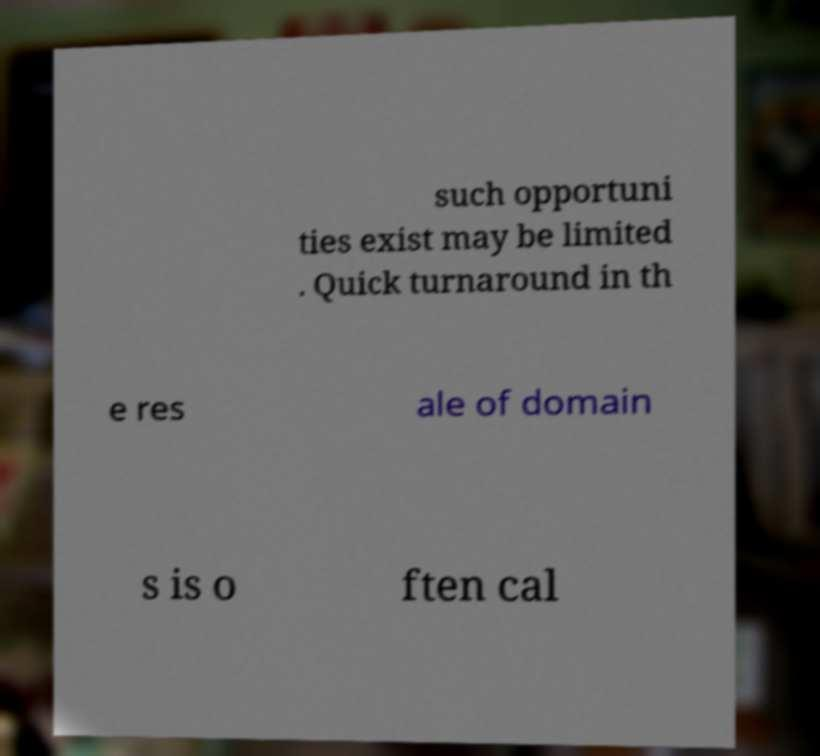What messages or text are displayed in this image? I need them in a readable, typed format. such opportuni ties exist may be limited . Quick turnaround in th e res ale of domain s is o ften cal 